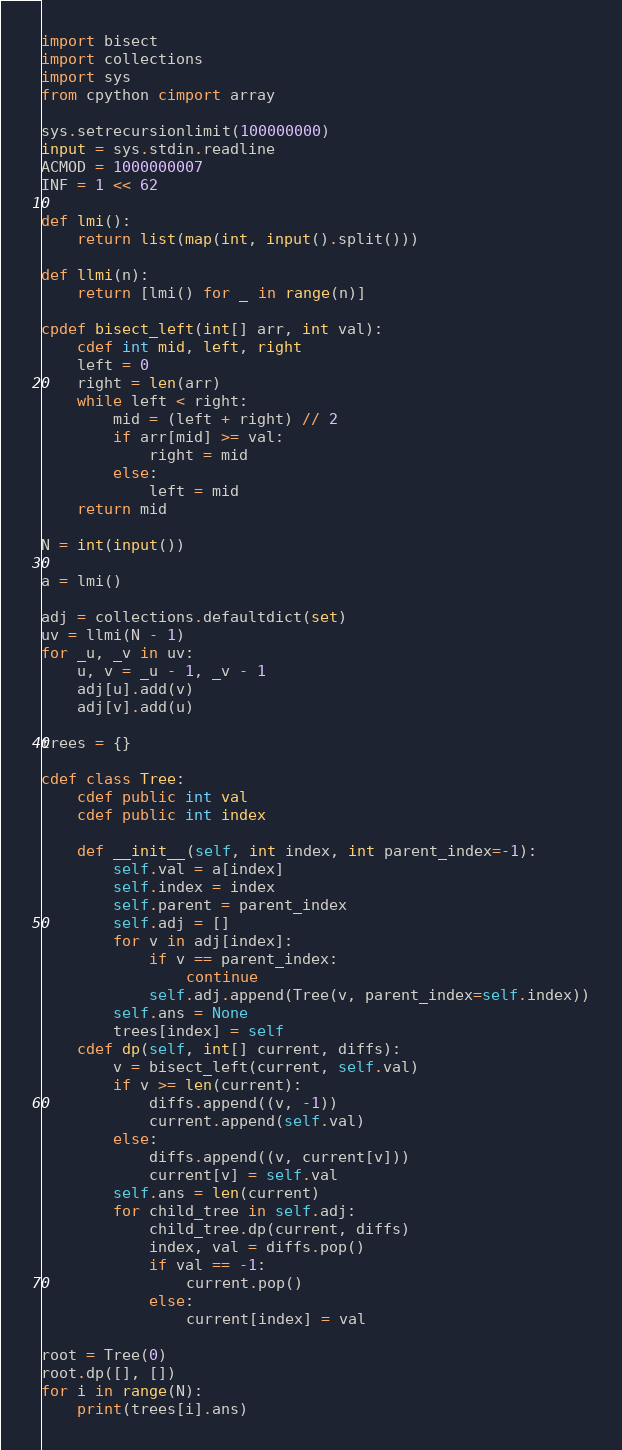<code> <loc_0><loc_0><loc_500><loc_500><_Cython_>import bisect
import collections
import sys
from cpython cimport array

sys.setrecursionlimit(100000000)
input = sys.stdin.readline
ACMOD = 1000000007
INF = 1 << 62

def lmi():
    return list(map(int, input().split()))

def llmi(n):
    return [lmi() for _ in range(n)]

cpdef bisect_left(int[] arr, int val):
    cdef int mid, left, right
    left = 0
    right = len(arr)
    while left < right:
        mid = (left + right) // 2
        if arr[mid] >= val:
            right = mid
        else:
            left = mid
    return mid

N = int(input())

a = lmi()

adj = collections.defaultdict(set)
uv = llmi(N - 1)
for _u, _v in uv:
    u, v = _u - 1, _v - 1
    adj[u].add(v)
    adj[v].add(u)

trees = {}

cdef class Tree:
    cdef public int val
    cdef public int index

    def __init__(self, int index, int parent_index=-1):
        self.val = a[index]
        self.index = index
        self.parent = parent_index
        self.adj = []
        for v in adj[index]:
            if v == parent_index:
                continue
            self.adj.append(Tree(v, parent_index=self.index))
        self.ans = None
        trees[index] = self
    cdef dp(self, int[] current, diffs):
        v = bisect_left(current, self.val)
        if v >= len(current):
            diffs.append((v, -1))
            current.append(self.val)
        else:
            diffs.append((v, current[v]))
            current[v] = self.val
        self.ans = len(current)
        for child_tree in self.adj:
            child_tree.dp(current, diffs)
            index, val = diffs.pop()
            if val == -1:
                current.pop()
            else:
                current[index] = val

root = Tree(0)
root.dp([], [])
for i in range(N):
    print(trees[i].ans)
</code> 